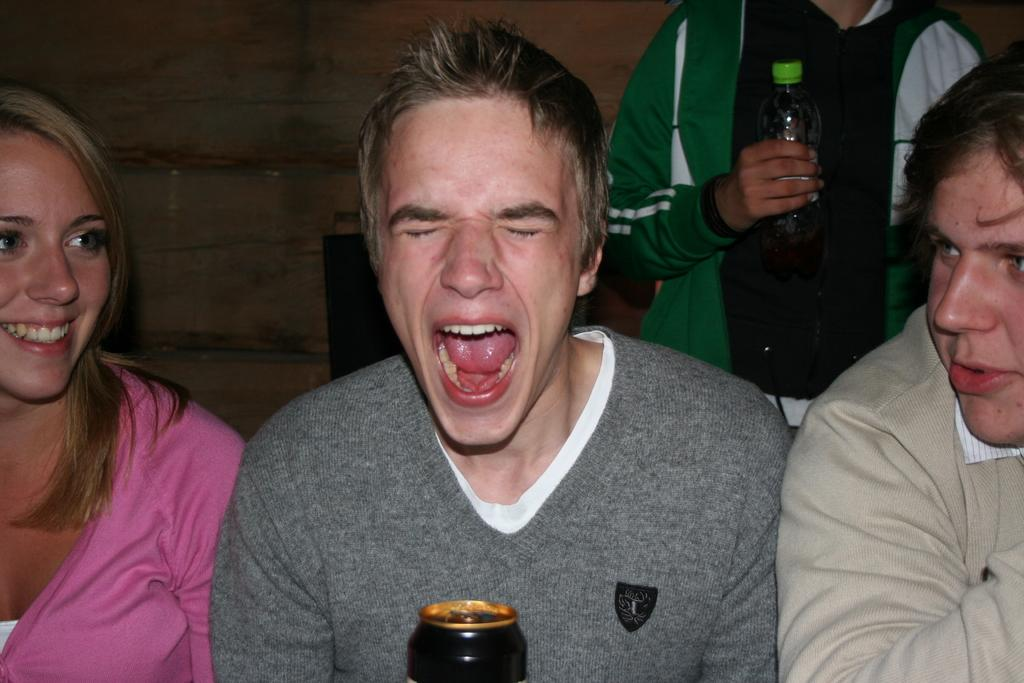How many people are in the image? There are four people in the image. What is the man in the front doing? The man sitting in the front is shouting. Can you describe the position of the man holding a bottle? There is a man behind the others holding a bottle. How many flocks of birds can be seen in the image? There are no flocks of birds present in the image. What level of expertise does the man holding a bottle have in the subject being discussed? The image does not provide any information about the man's level of expertise in the subject being discussed. 